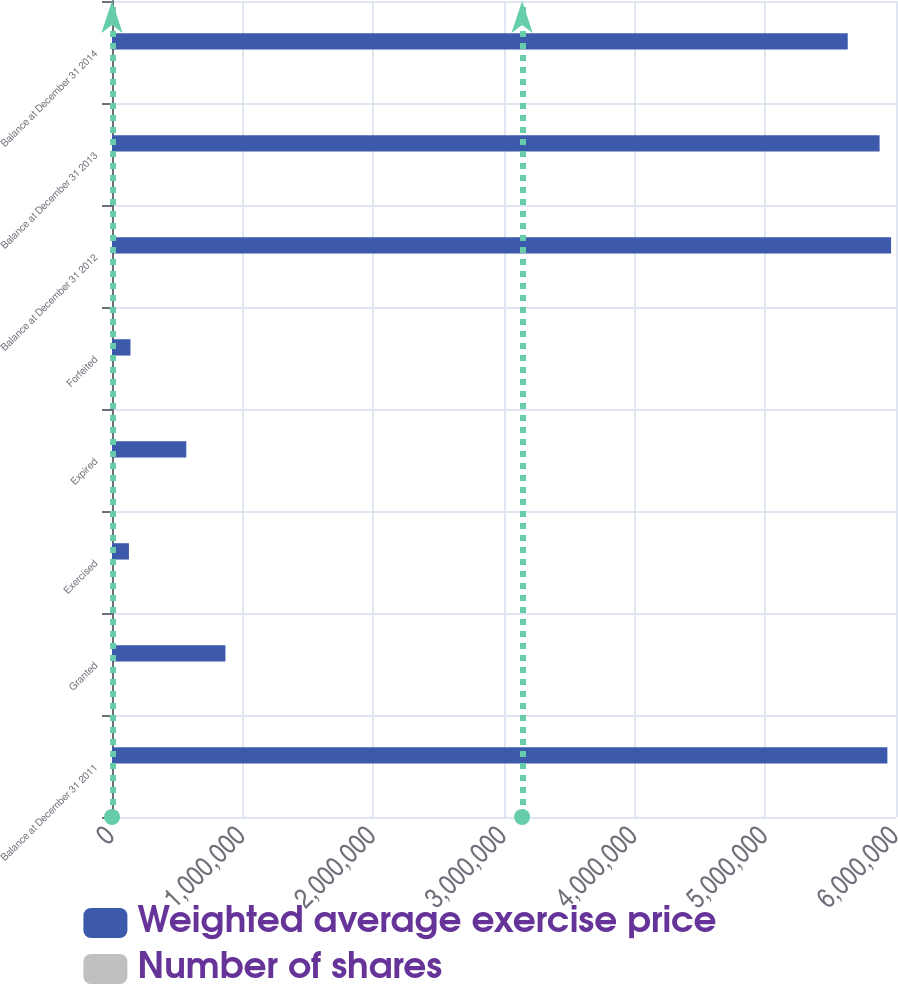Convert chart to OTSL. <chart><loc_0><loc_0><loc_500><loc_500><stacked_bar_chart><ecel><fcel>Balance at December 31 2011<fcel>Granted<fcel>Exercised<fcel>Expired<fcel>Forfeited<fcel>Balance at December 31 2012<fcel>Balance at December 31 2013<fcel>Balance at December 31 2014<nl><fcel>Weighted average exercise price<fcel>5.93387e+06<fcel>867968<fcel>129616<fcel>568546<fcel>141351<fcel>5.96232e+06<fcel>5.87459e+06<fcel>5.6305e+06<nl><fcel>Number of shares<fcel>43.06<fcel>18.87<fcel>14.64<fcel>61.9<fcel>21.36<fcel>38.87<fcel>35.54<fcel>31.6<nl></chart> 